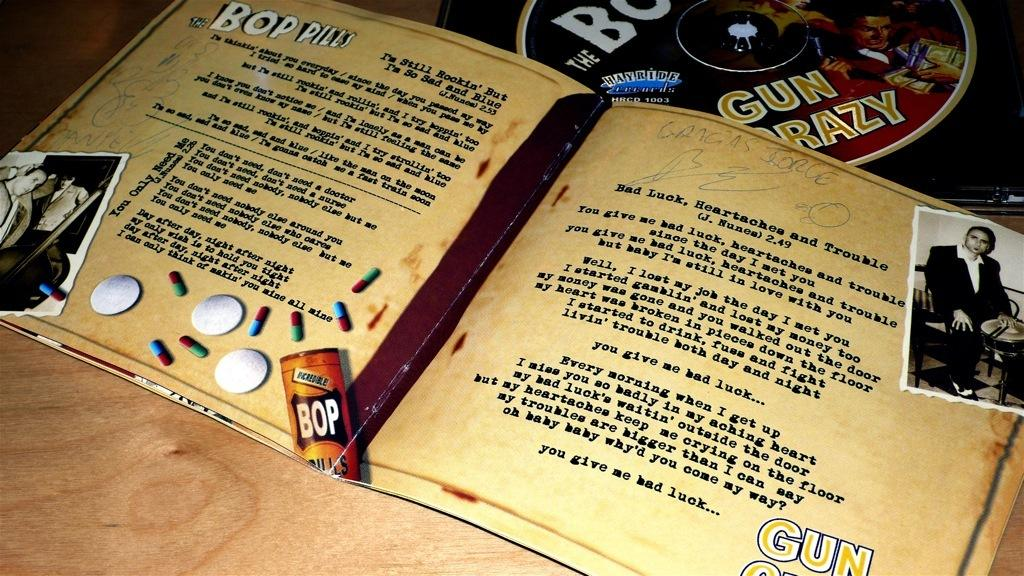Provide a one-sentence caption for the provided image. Liner notes for a Bop Pills CD are open and laying on a table by the disc. 